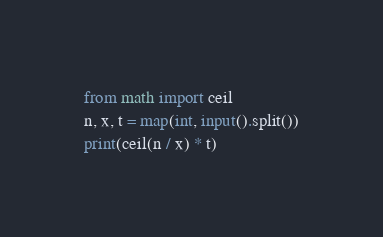Convert code to text. <code><loc_0><loc_0><loc_500><loc_500><_Python_>from math import ceil
n, x, t = map(int, input().split())
print(ceil(n / x) * t)</code> 